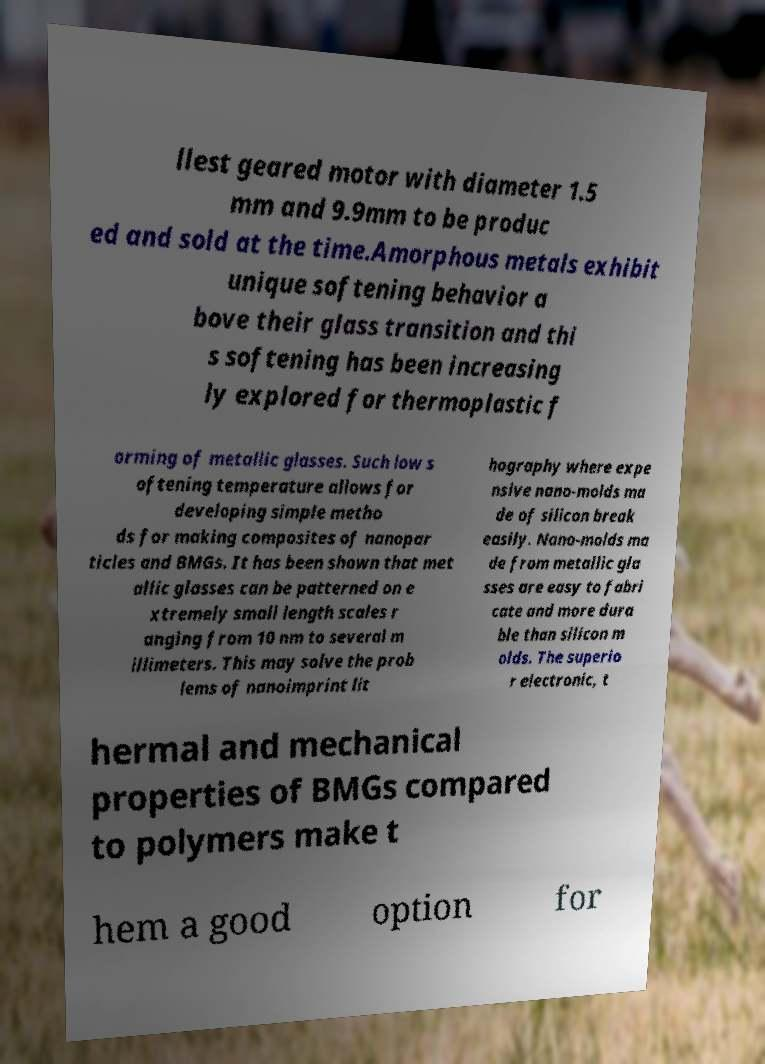There's text embedded in this image that I need extracted. Can you transcribe it verbatim? llest geared motor with diameter 1.5 mm and 9.9mm to be produc ed and sold at the time.Amorphous metals exhibit unique softening behavior a bove their glass transition and thi s softening has been increasing ly explored for thermoplastic f orming of metallic glasses. Such low s oftening temperature allows for developing simple metho ds for making composites of nanopar ticles and BMGs. It has been shown that met allic glasses can be patterned on e xtremely small length scales r anging from 10 nm to several m illimeters. This may solve the prob lems of nanoimprint lit hography where expe nsive nano-molds ma de of silicon break easily. Nano-molds ma de from metallic gla sses are easy to fabri cate and more dura ble than silicon m olds. The superio r electronic, t hermal and mechanical properties of BMGs compared to polymers make t hem a good option for 